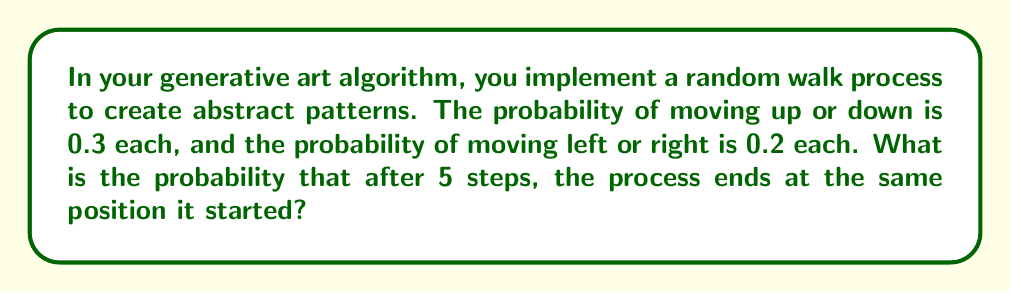Could you help me with this problem? Let's approach this step-by-step:

1) First, we need to understand what it means to end at the same position after 5 steps. This can happen if:
   - The number of up moves equals the number of down moves, AND
   - The number of left moves equals the number of right moves

2) We can use the binomial probability formula to calculate this. Let's break it down into vertical and horizontal movements:

3) For vertical movement:
   - We need an even number of steps (0, 2, or 4) to cancel out
   - Probability of no vertical movement in 5 steps:
     $$P(\text{0 vertical}) = \binom{5}{0}(0.3)^0(0.7)^5 = 0.16807$$
   - Probability of 2 up and 2 down in 5 steps:
     $$P(\text{2 up, 2 down}) = \binom{5}{2}(0.3)^2(0.3)^2(0.4)^1 = 0.0486$$

4) For horizontal movement:
   - We need an even number of steps (0, 2, or 4) to cancel out
   - Probability of no horizontal movement in 5 steps:
     $$P(\text{0 horizontal}) = \binom{5}{0}(0.2)^0(0.8)^5 = 0.32768$$
   - Probability of 2 left and 2 right in 5 steps:
     $$P(\text{2 left, 2 right}) = \binom{5}{2}(0.2)^2(0.2)^2(0.6)^1 = 0.0192$$

5) The total probability is the product of the probabilities for vertical and horizontal movements:
   $$P(\text{same position}) = (0.16807 + 0.0486)(0.32768 + 0.0192) = 0.216667 * 0.34688 = 0.0751$$

Therefore, the probability of ending at the same position after 5 steps is approximately 0.0751 or 7.51%.
Answer: 0.0751 